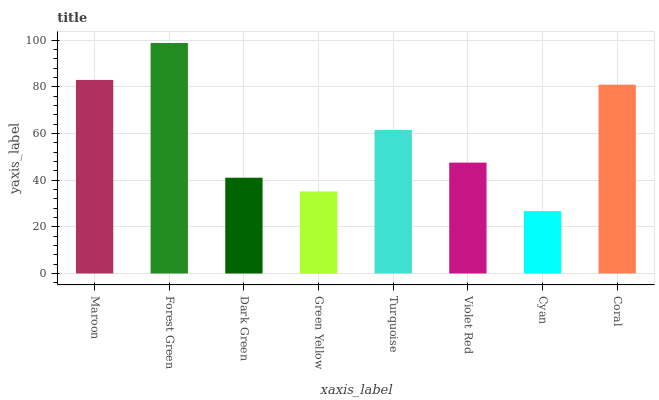Is Cyan the minimum?
Answer yes or no. Yes. Is Forest Green the maximum?
Answer yes or no. Yes. Is Dark Green the minimum?
Answer yes or no. No. Is Dark Green the maximum?
Answer yes or no. No. Is Forest Green greater than Dark Green?
Answer yes or no. Yes. Is Dark Green less than Forest Green?
Answer yes or no. Yes. Is Dark Green greater than Forest Green?
Answer yes or no. No. Is Forest Green less than Dark Green?
Answer yes or no. No. Is Turquoise the high median?
Answer yes or no. Yes. Is Violet Red the low median?
Answer yes or no. Yes. Is Violet Red the high median?
Answer yes or no. No. Is Cyan the low median?
Answer yes or no. No. 